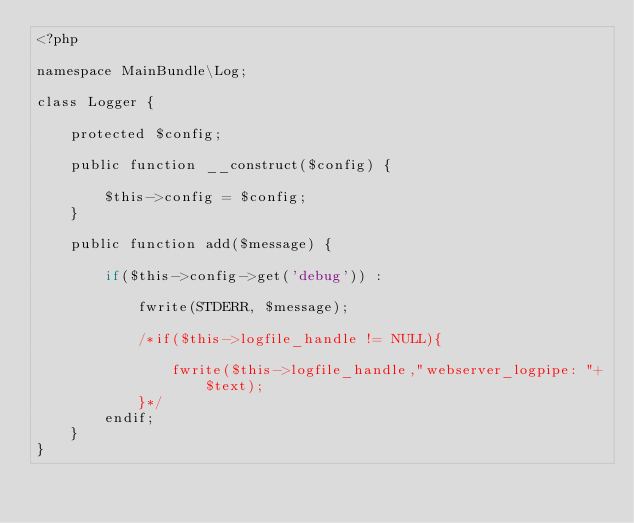Convert code to text. <code><loc_0><loc_0><loc_500><loc_500><_PHP_><?php

namespace MainBundle\Log;

class Logger {

    protected $config;

    public function __construct($config) {

        $this->config = $config;
    }

    public function add($message) {

        if($this->config->get('debug')) :

            fwrite(STDERR, $message);

            /*if($this->logfile_handle != NULL){

                fwrite($this->logfile_handle,"webserver_logpipe: "+$text);
            }*/
        endif;
    }
}</code> 